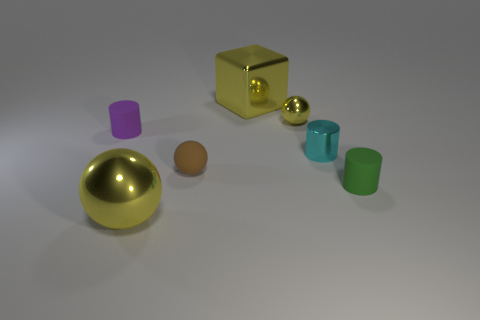Add 3 large blue matte cylinders. How many objects exist? 10 Subtract all cubes. How many objects are left? 6 Subtract all small yellow objects. Subtract all green matte things. How many objects are left? 5 Add 4 small yellow metal things. How many small yellow metal things are left? 5 Add 2 large yellow rubber things. How many large yellow rubber things exist? 2 Subtract 0 brown cubes. How many objects are left? 7 